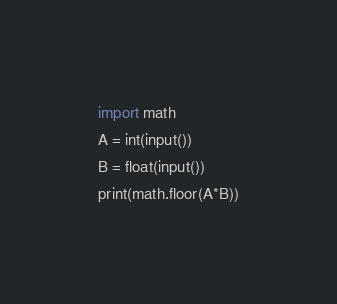<code> <loc_0><loc_0><loc_500><loc_500><_Python_>import math
A = int(input())
B = float(input())
print(math.floor(A*B))</code> 